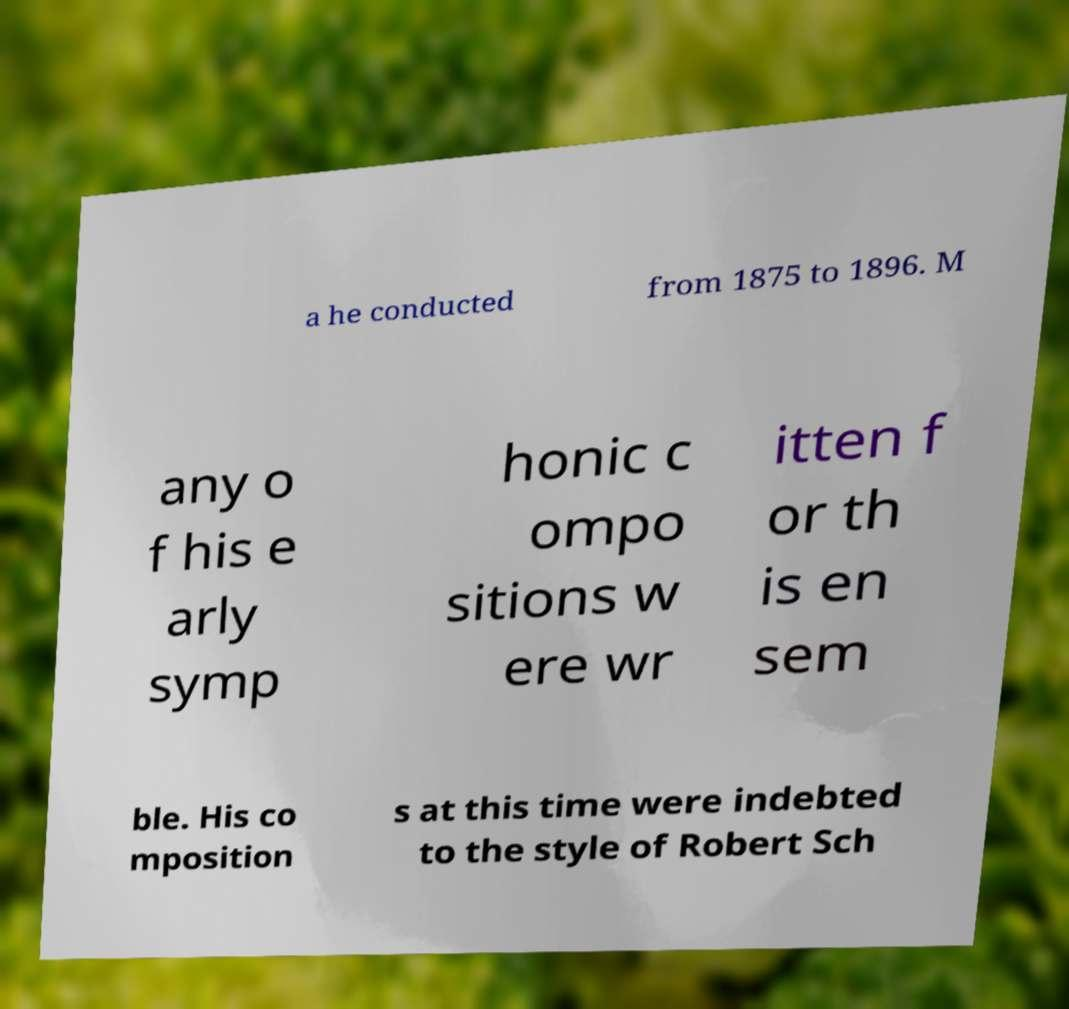Please identify and transcribe the text found in this image. a he conducted from 1875 to 1896. M any o f his e arly symp honic c ompo sitions w ere wr itten f or th is en sem ble. His co mposition s at this time were indebted to the style of Robert Sch 